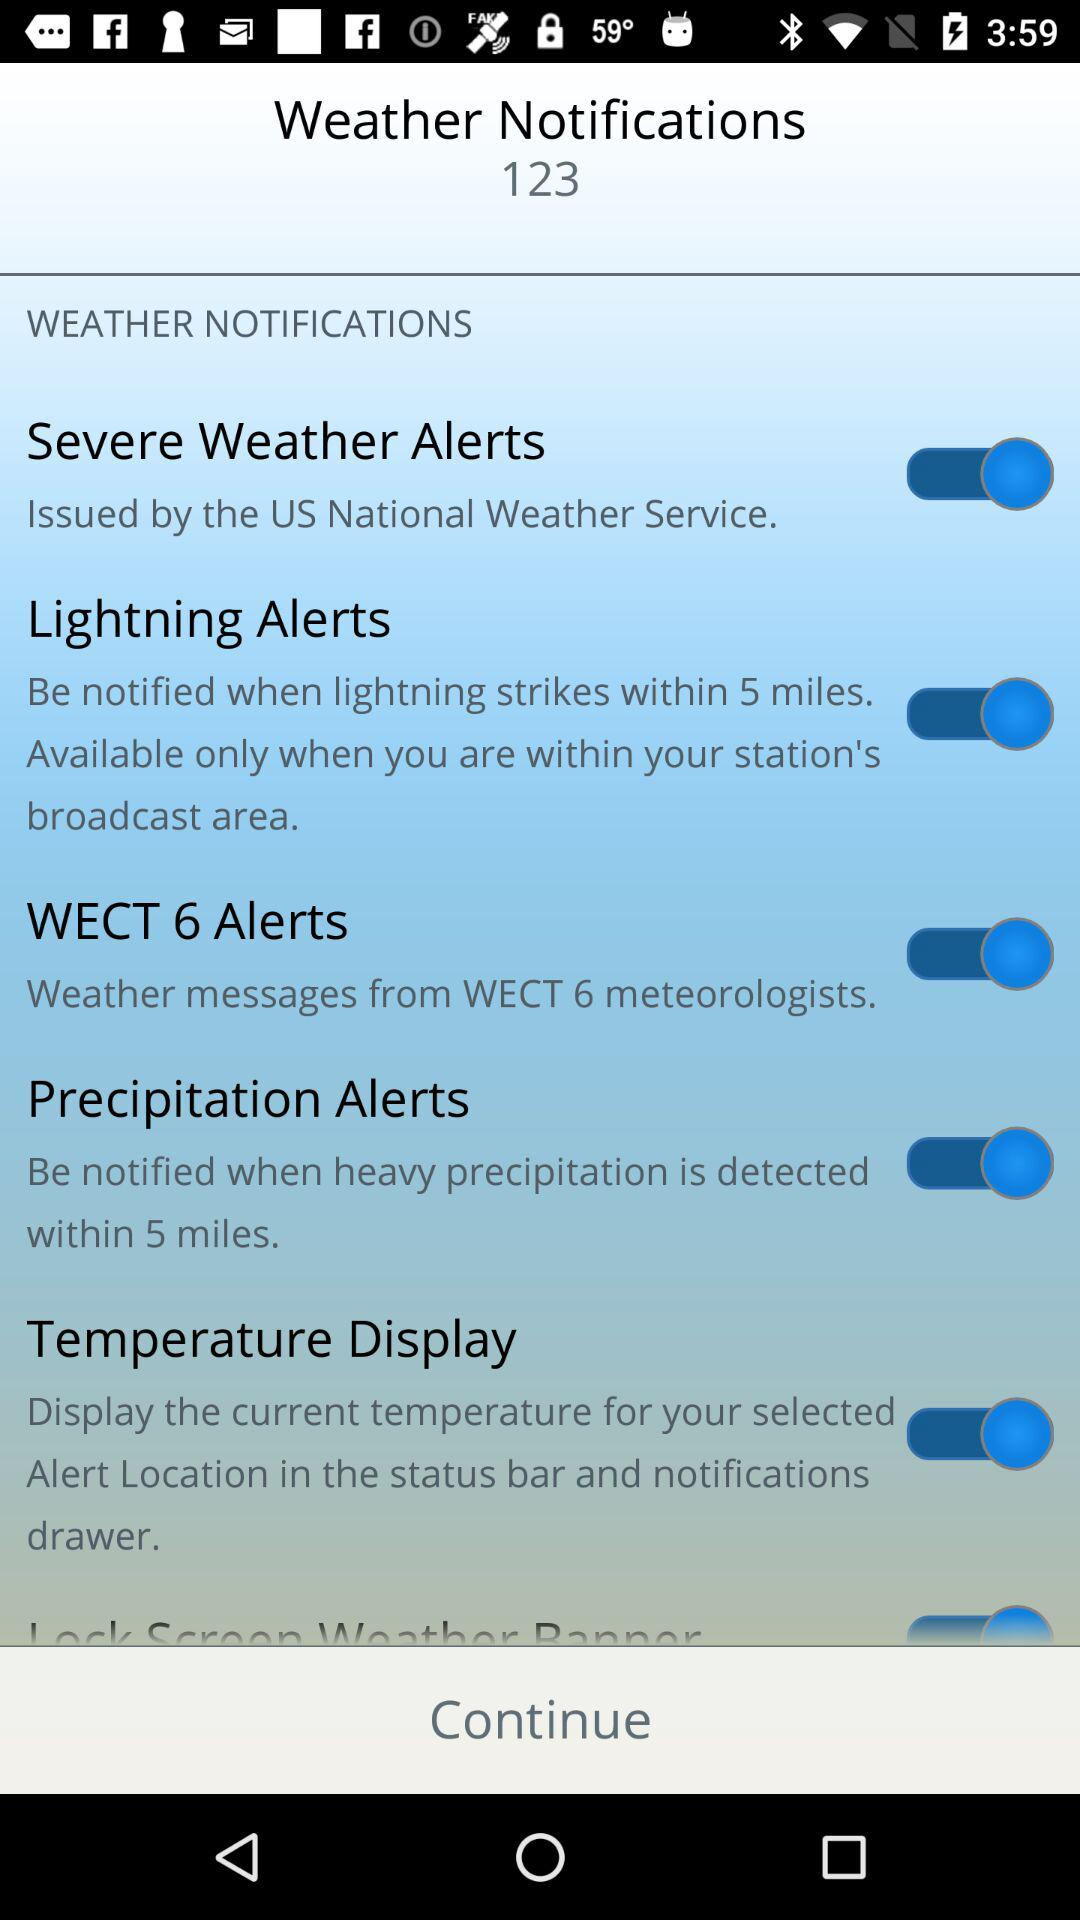How many of the weather alerts are issued by the US National Weather Service?
Answer the question using a single word or phrase. 1 